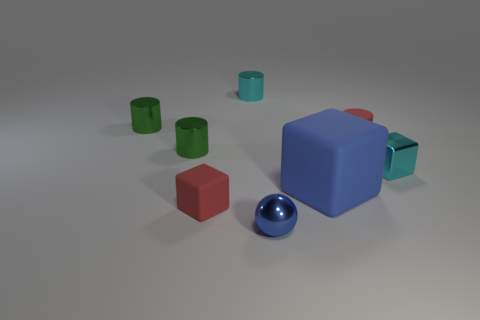How many green cylinders must be subtracted to get 1 green cylinders? 1 Add 2 blue matte objects. How many objects exist? 10 Subtract all blocks. How many objects are left? 5 Subtract all red objects. Subtract all tiny metallic cylinders. How many objects are left? 3 Add 3 matte cylinders. How many matte cylinders are left? 4 Add 7 large purple spheres. How many large purple spheres exist? 7 Subtract 0 purple cylinders. How many objects are left? 8 